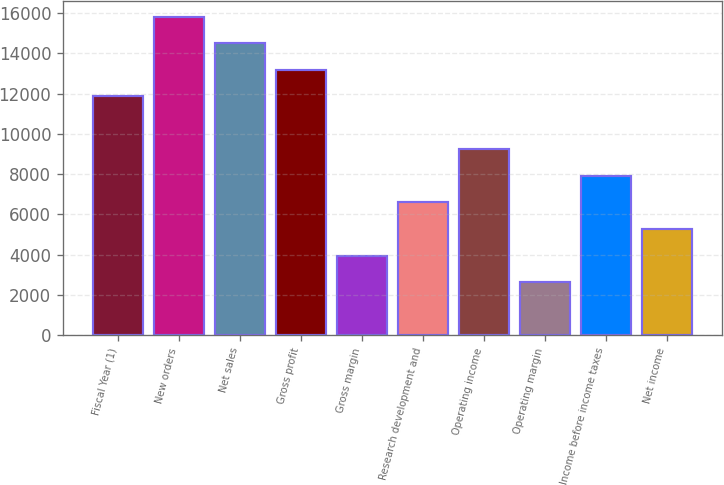Convert chart. <chart><loc_0><loc_0><loc_500><loc_500><bar_chart><fcel>Fiscal Year (1)<fcel>New orders<fcel>Net sales<fcel>Gross profit<fcel>Gross margin<fcel>Research development and<fcel>Operating income<fcel>Operating margin<fcel>Income before income taxes<fcel>Net income<nl><fcel>11856.6<fcel>15808.7<fcel>14491.4<fcel>13174<fcel>3952.48<fcel>6587.2<fcel>9221.92<fcel>2635.12<fcel>7904.56<fcel>5269.84<nl></chart> 